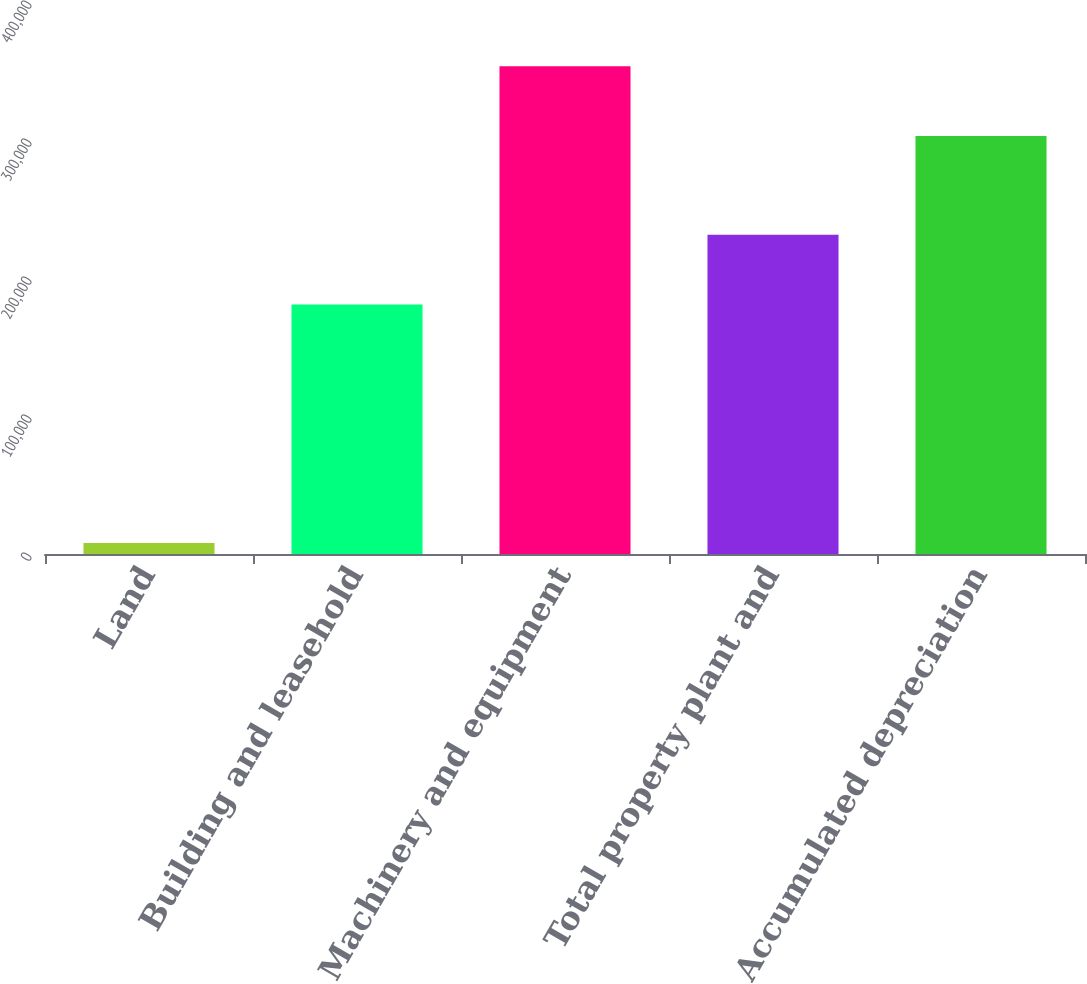<chart> <loc_0><loc_0><loc_500><loc_500><bar_chart><fcel>Land<fcel>Building and leasehold<fcel>Machinery and equipment<fcel>Total property plant and<fcel>Accumulated depreciation<nl><fcel>8050<fcel>180821<fcel>353506<fcel>231364<fcel>302963<nl></chart> 